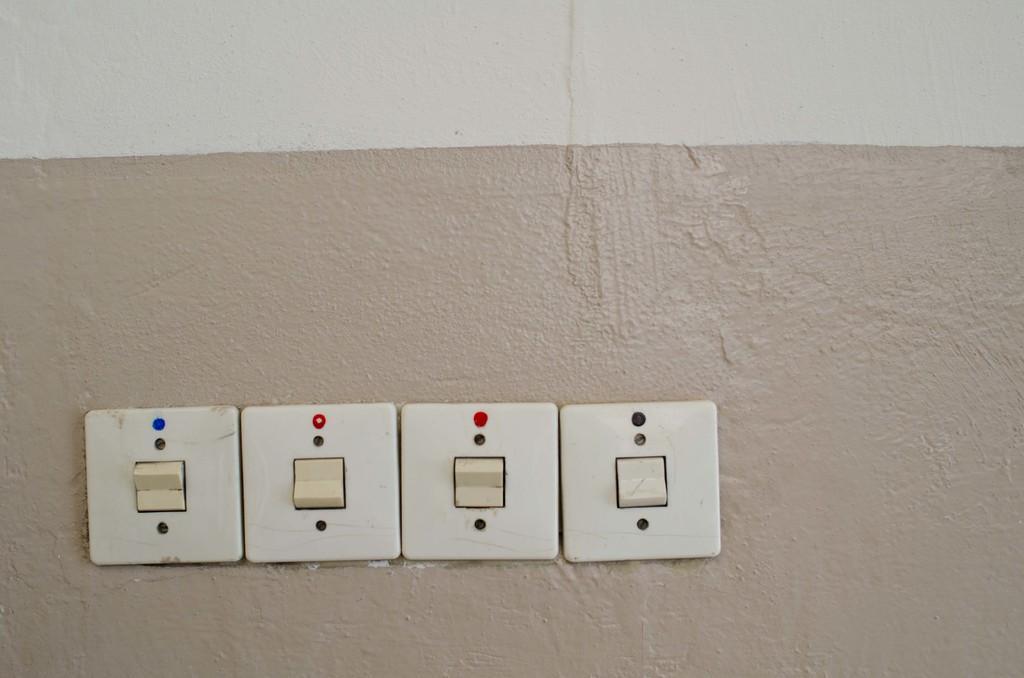Can you describe this image briefly? There are 4 switches on a wall. 